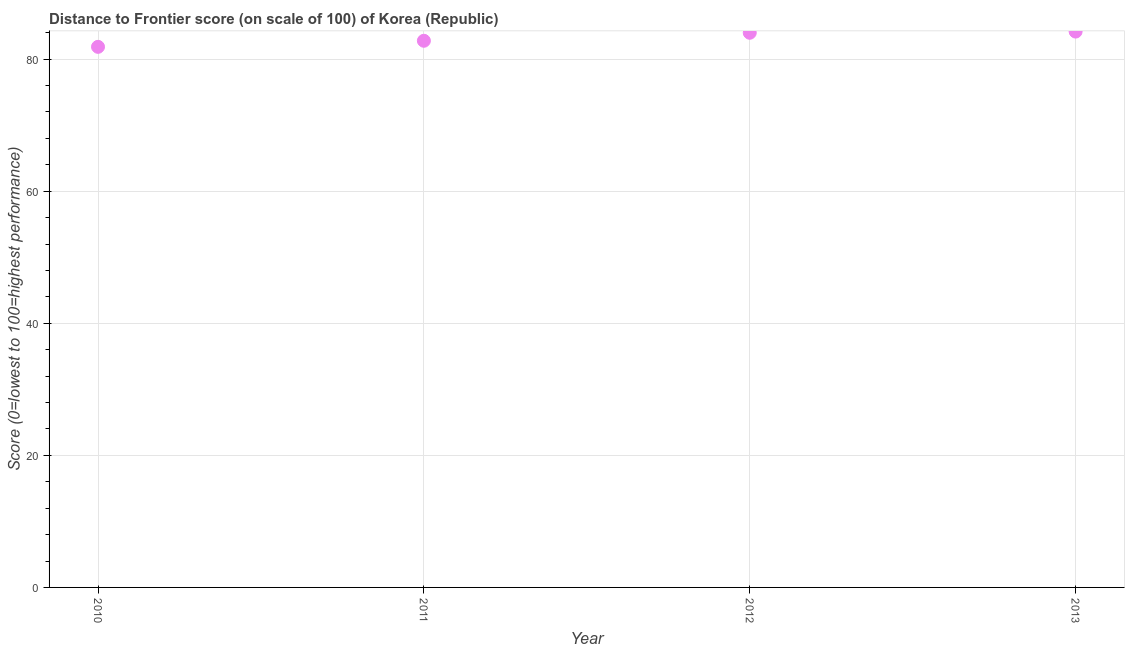What is the distance to frontier score in 2011?
Your answer should be very brief. 82.78. Across all years, what is the maximum distance to frontier score?
Your response must be concise. 84.17. Across all years, what is the minimum distance to frontier score?
Offer a terse response. 81.86. In which year was the distance to frontier score maximum?
Your answer should be very brief. 2013. What is the sum of the distance to frontier score?
Make the answer very short. 332.8. What is the difference between the distance to frontier score in 2011 and 2013?
Offer a terse response. -1.39. What is the average distance to frontier score per year?
Make the answer very short. 83.2. What is the median distance to frontier score?
Make the answer very short. 83.38. In how many years, is the distance to frontier score greater than 76 ?
Ensure brevity in your answer.  4. Do a majority of the years between 2011 and 2013 (inclusive) have distance to frontier score greater than 36 ?
Provide a short and direct response. Yes. What is the ratio of the distance to frontier score in 2011 to that in 2013?
Give a very brief answer. 0.98. Is the difference between the distance to frontier score in 2010 and 2011 greater than the difference between any two years?
Make the answer very short. No. What is the difference between the highest and the second highest distance to frontier score?
Your response must be concise. 0.18. Is the sum of the distance to frontier score in 2010 and 2012 greater than the maximum distance to frontier score across all years?
Make the answer very short. Yes. What is the difference between the highest and the lowest distance to frontier score?
Ensure brevity in your answer.  2.31. In how many years, is the distance to frontier score greater than the average distance to frontier score taken over all years?
Offer a terse response. 2. Does the distance to frontier score monotonically increase over the years?
Give a very brief answer. Yes. How many dotlines are there?
Offer a very short reply. 1. Are the values on the major ticks of Y-axis written in scientific E-notation?
Your answer should be compact. No. Does the graph contain grids?
Ensure brevity in your answer.  Yes. What is the title of the graph?
Give a very brief answer. Distance to Frontier score (on scale of 100) of Korea (Republic). What is the label or title of the Y-axis?
Provide a short and direct response. Score (0=lowest to 100=highest performance). What is the Score (0=lowest to 100=highest performance) in 2010?
Your response must be concise. 81.86. What is the Score (0=lowest to 100=highest performance) in 2011?
Offer a terse response. 82.78. What is the Score (0=lowest to 100=highest performance) in 2012?
Your answer should be compact. 83.99. What is the Score (0=lowest to 100=highest performance) in 2013?
Give a very brief answer. 84.17. What is the difference between the Score (0=lowest to 100=highest performance) in 2010 and 2011?
Your answer should be compact. -0.92. What is the difference between the Score (0=lowest to 100=highest performance) in 2010 and 2012?
Your answer should be very brief. -2.13. What is the difference between the Score (0=lowest to 100=highest performance) in 2010 and 2013?
Provide a short and direct response. -2.31. What is the difference between the Score (0=lowest to 100=highest performance) in 2011 and 2012?
Keep it short and to the point. -1.21. What is the difference between the Score (0=lowest to 100=highest performance) in 2011 and 2013?
Give a very brief answer. -1.39. What is the difference between the Score (0=lowest to 100=highest performance) in 2012 and 2013?
Offer a terse response. -0.18. What is the ratio of the Score (0=lowest to 100=highest performance) in 2010 to that in 2011?
Keep it short and to the point. 0.99. What is the ratio of the Score (0=lowest to 100=highest performance) in 2010 to that in 2012?
Provide a short and direct response. 0.97. What is the ratio of the Score (0=lowest to 100=highest performance) in 2011 to that in 2012?
Offer a terse response. 0.99. What is the ratio of the Score (0=lowest to 100=highest performance) in 2011 to that in 2013?
Your response must be concise. 0.98. 